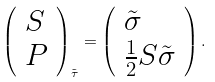<formula> <loc_0><loc_0><loc_500><loc_500>\left ( \begin{array} { l } S \\ P \end{array} \right ) _ { \tilde { \tau } } = \left ( \begin{array} { l } \tilde { \sigma } \\ \frac { 1 } { 2 } S \tilde { \sigma } \end{array} \right ) .</formula> 